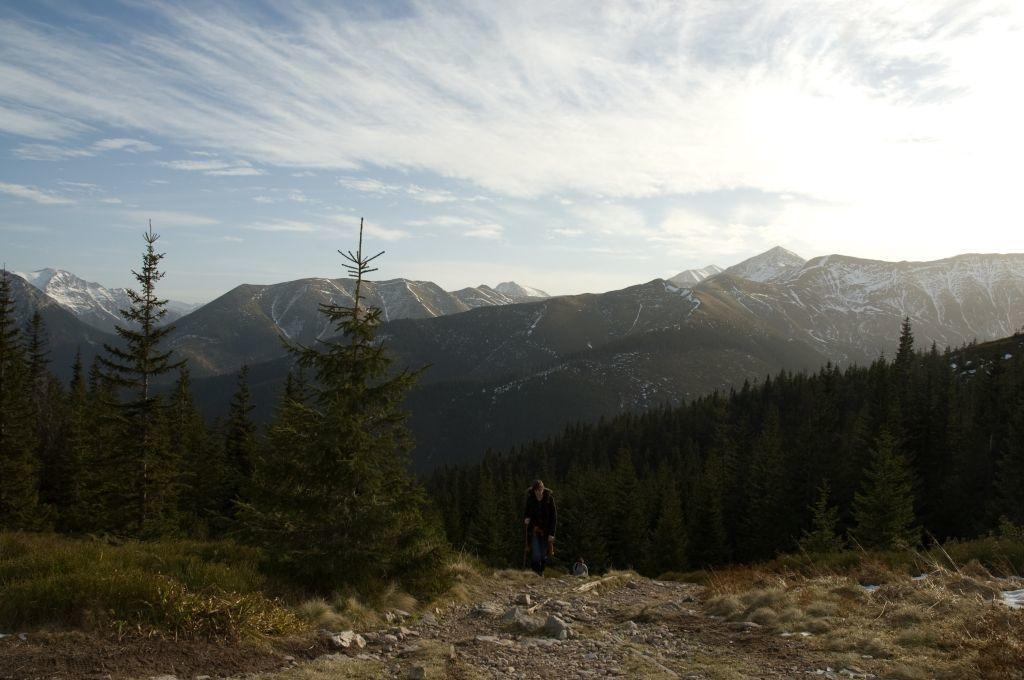What type of vegetation can be seen in the image? There are trees in the image. What type of natural landform is visible in the background of the image? There are mountains in the background of the image. What is visible in the sky in the image? The sky is clear and visible in the background of the image. Where is the faucet located in the image? There is no faucet present in the image. What type of lead can be seen in the image? There is no lead present in the image. 